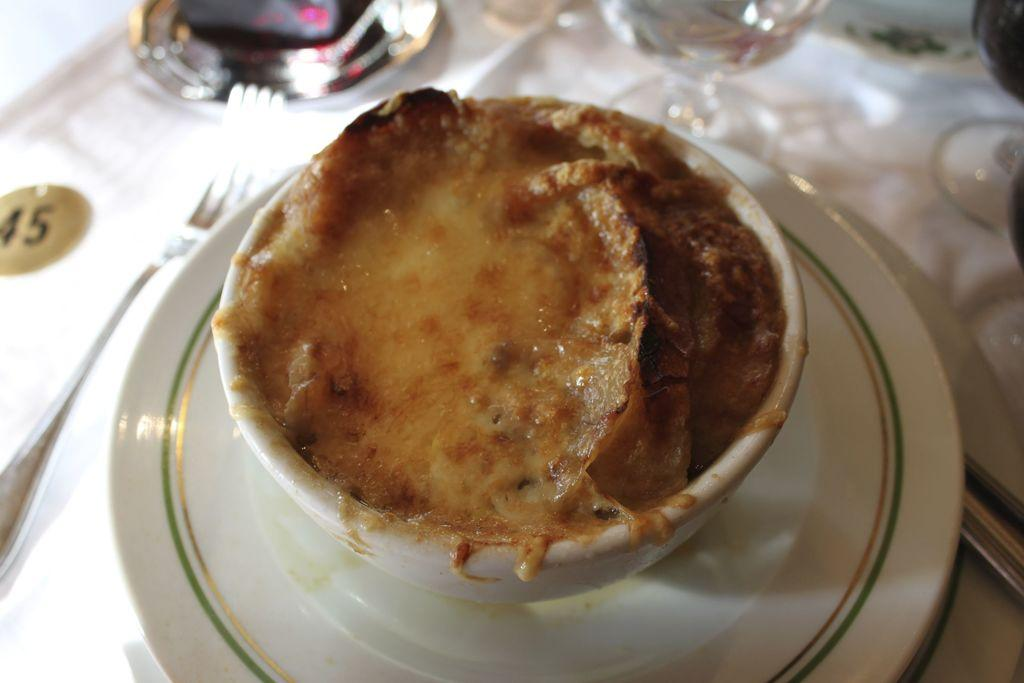What is in the bowl that is visible in the image? There is food in a bowl in the image. What is the color of the plate that the bowl is on? The plate is white in color. What utensil is visible in the image? There is a fork visible in the image. What type of container is present in the image? There is a glass in the image. What is the color of the cloth on which objects are placed? The cloth is white in color. What type of ornament is hanging from the glass in the image? There is no ornament hanging from the glass in the image. What type of nut is present in the bowl with the food? There is no nut present in the bowl with the food; it contains only food. 